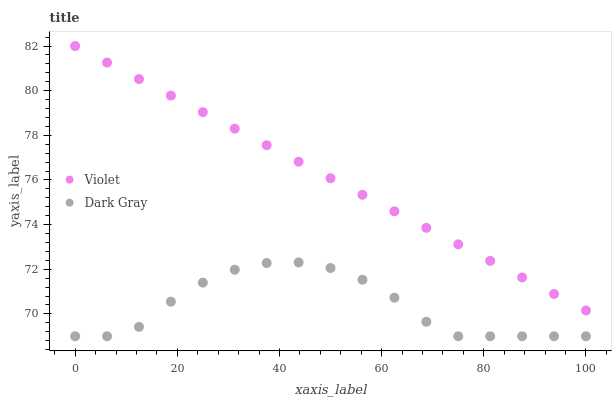Does Dark Gray have the minimum area under the curve?
Answer yes or no. Yes. Does Violet have the maximum area under the curve?
Answer yes or no. Yes. Does Violet have the minimum area under the curve?
Answer yes or no. No. Is Violet the smoothest?
Answer yes or no. Yes. Is Dark Gray the roughest?
Answer yes or no. Yes. Is Violet the roughest?
Answer yes or no. No. Does Dark Gray have the lowest value?
Answer yes or no. Yes. Does Violet have the lowest value?
Answer yes or no. No. Does Violet have the highest value?
Answer yes or no. Yes. Is Dark Gray less than Violet?
Answer yes or no. Yes. Is Violet greater than Dark Gray?
Answer yes or no. Yes. Does Dark Gray intersect Violet?
Answer yes or no. No. 